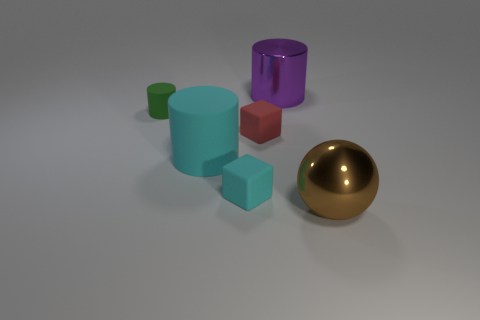Subtract all big cylinders. How many cylinders are left? 1 Add 1 small green rubber objects. How many objects exist? 7 Subtract all purple cylinders. How many cylinders are left? 2 Subtract 1 balls. How many balls are left? 0 Subtract all red blocks. How many yellow cylinders are left? 0 Subtract all small gray rubber cubes. Subtract all cyan cylinders. How many objects are left? 5 Add 5 cyan rubber cubes. How many cyan rubber cubes are left? 6 Add 1 blue rubber balls. How many blue rubber balls exist? 1 Subtract 0 yellow balls. How many objects are left? 6 Subtract all balls. How many objects are left? 5 